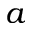<formula> <loc_0><loc_0><loc_500><loc_500>a</formula> 